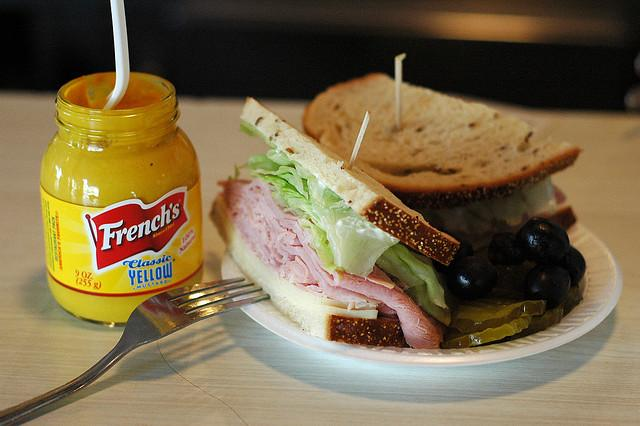Which one of these is a competitor of the company that make's the item in the jar? Please explain your reasoning. gulden's. Gulden's is another brand of mustard. 